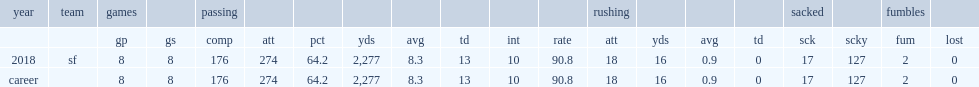How many passing yards did mullens get in 2018? 2277.0. 